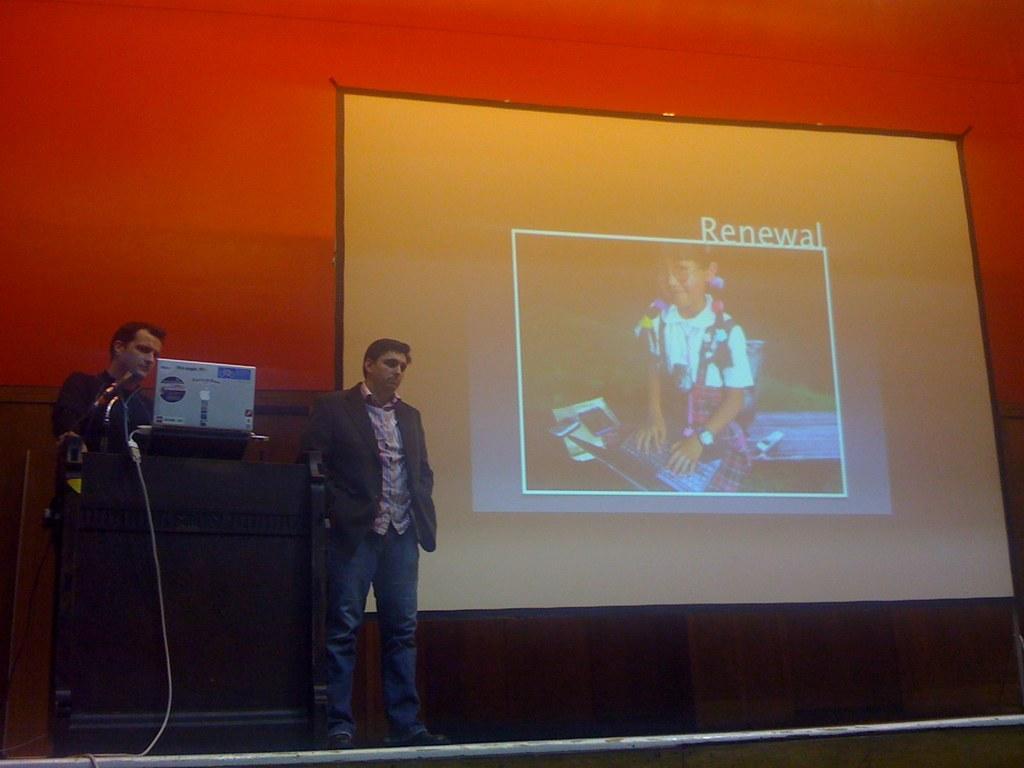Please provide a concise description of this image. In this image two people are standing on the stage. In front of them there is a dais. On top of it there is a laptop. Behind them there is a projector. At the back side there is a wall. 